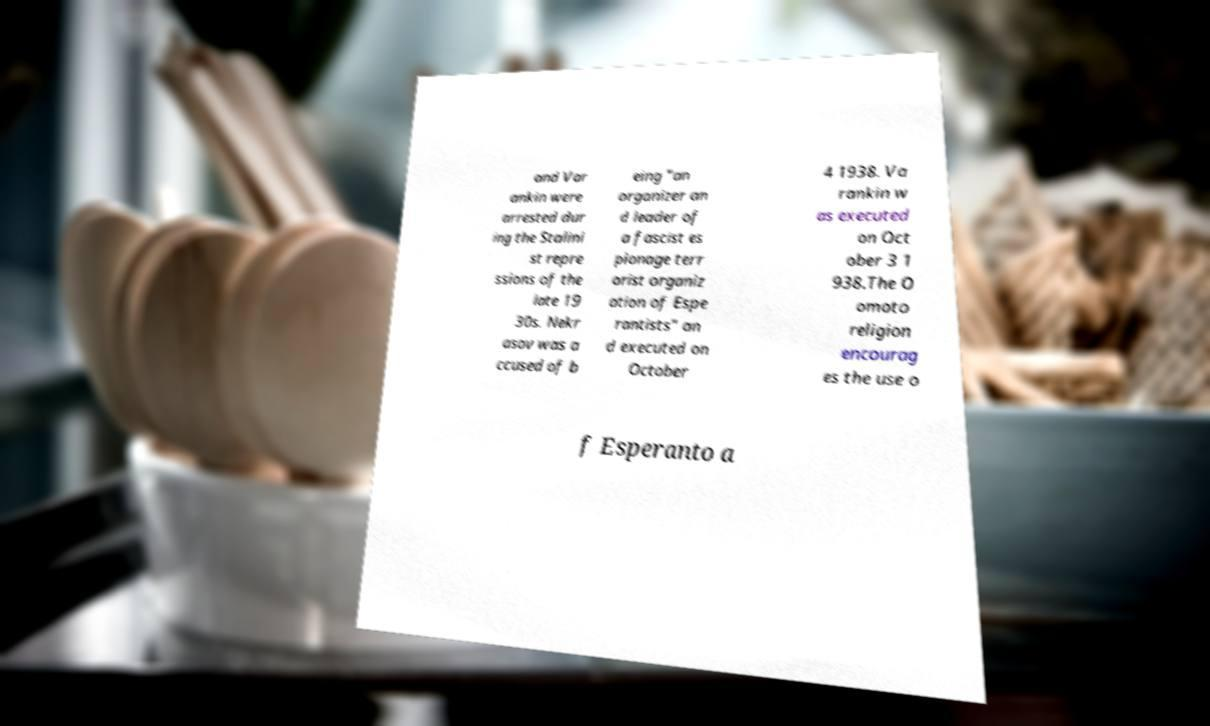Please read and relay the text visible in this image. What does it say? and Var ankin were arrested dur ing the Stalini st repre ssions of the late 19 30s. Nekr asov was a ccused of b eing "an organizer an d leader of a fascist es pionage terr orist organiz ation of Espe rantists" an d executed on October 4 1938. Va rankin w as executed on Oct ober 3 1 938.The O omoto religion encourag es the use o f Esperanto a 